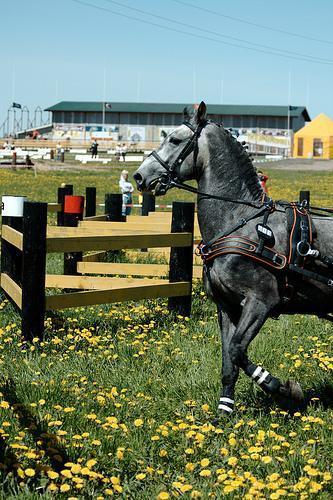How many horses are there?
Give a very brief answer. 1. 